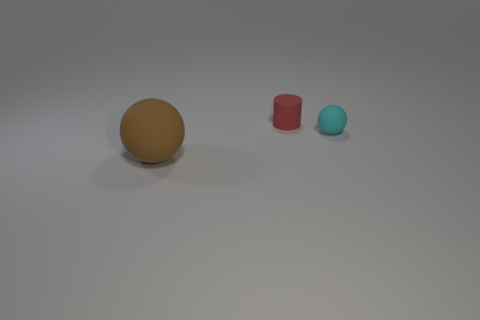Add 2 green metallic spheres. How many objects exist? 5 Subtract all cylinders. How many objects are left? 2 Subtract 0 red spheres. How many objects are left? 3 Subtract all green balls. Subtract all brown cubes. How many balls are left? 2 Subtract all small red rubber spheres. Subtract all small red rubber cylinders. How many objects are left? 2 Add 2 cyan matte balls. How many cyan matte balls are left? 3 Add 2 cyan rubber things. How many cyan rubber things exist? 3 